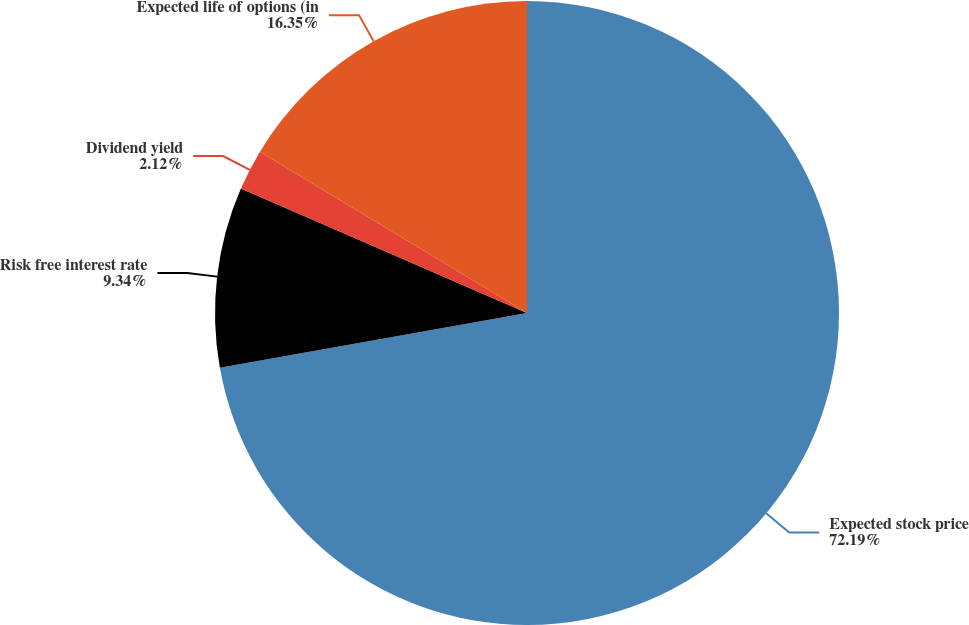Convert chart. <chart><loc_0><loc_0><loc_500><loc_500><pie_chart><fcel>Expected stock price<fcel>Risk free interest rate<fcel>Dividend yield<fcel>Expected life of options (in<nl><fcel>72.19%<fcel>9.34%<fcel>2.12%<fcel>16.35%<nl></chart> 